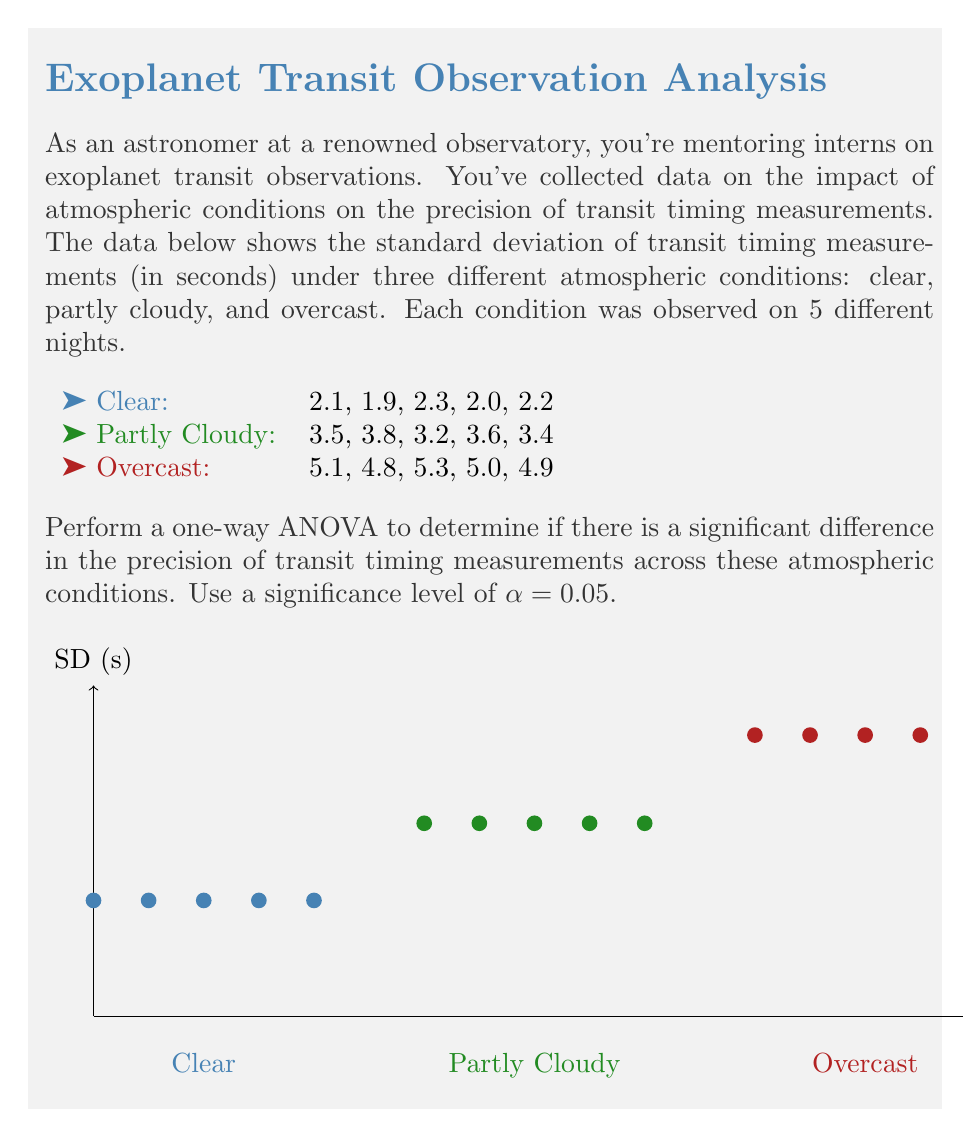Help me with this question. Let's perform the one-way ANOVA step by step:

1) First, calculate the means for each group:
   Clear: $\bar{x}_1 = 2.1$
   Partly Cloudy: $\bar{x}_2 = 3.5$
   Overcast: $\bar{x}_3 = 5.02$

2) Calculate the grand mean:
   $\bar{x} = \frac{2.1 + 3.5 + 5.02}{3} = 3.54$

3) Calculate the Sum of Squares Between (SSB):
   $$SSB = \sum_{i=1}^k n_i(\bar{x}_i - \bar{x})^2$$
   $$SSB = 5(2.1 - 3.54)^2 + 5(3.5 - 3.54)^2 + 5(5.02 - 3.54)^2 = 21.4468$$

4) Calculate the Sum of Squares Within (SSW):
   $$SSW = \sum_{i=1}^k\sum_{j=1}^{n_i} (x_{ij} - \bar{x}_i)^2$$
   $$SSW = 0.12 + 0.22 + 0.12 = 0.46$$

5) Calculate the Sum of Squares Total (SST):
   $$SST = SSB + SSW = 21.4468 + 0.46 = 21.9068$$

6) Calculate the degrees of freedom:
   Between groups: $df_B = k - 1 = 2$
   Within groups: $df_W = N - k = 12$
   Total: $df_T = N - 1 = 14$

7) Calculate the Mean Square Between (MSB) and Mean Square Within (MSW):
   $$MSB = \frac{SSB}{df_B} = \frac{21.4468}{2} = 10.7234$$
   $$MSW = \frac{SSW}{df_W} = \frac{0.46}{12} = 0.0383$$

8) Calculate the F-statistic:
   $$F = \frac{MSB}{MSW} = \frac{10.7234}{0.0383} = 279.98$$

9) Find the critical F-value:
   For α = 0.05, $df_B = 2$, and $df_W = 12$, the critical F-value is approximately 3.89.

10) Compare the F-statistic to the critical F-value:
    Since 279.98 > 3.89, we reject the null hypothesis.
Answer: $F(2,12) = 279.98, p < 0.05$. Significant difference exists. 